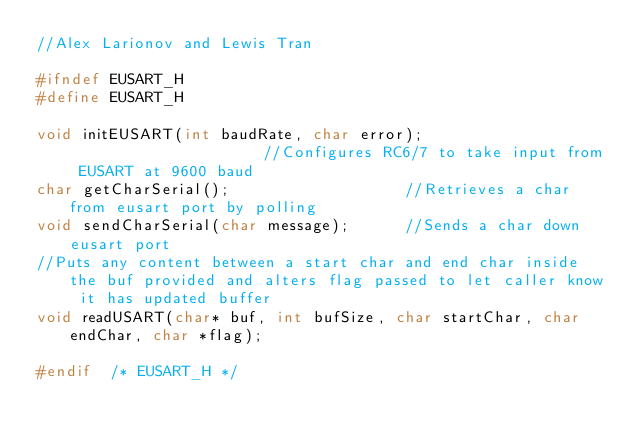<code> <loc_0><loc_0><loc_500><loc_500><_C_>//Alex Larionov and Lewis Tran

#ifndef EUSART_H
#define	EUSART_H

void initEUSART(int baudRate, char error);                      //Configures RC6/7 to take input from EUSART at 9600 baud
char getCharSerial();                   //Retrieves a char from eusart port by polling
void sendCharSerial(char message);      //Sends a char down eusart port 
//Puts any content between a start char and end char inside the buf provided and alters flag passed to let caller know it has updated buffer
void readUSART(char* buf, int bufSize, char startChar, char endChar, char *flag);   

#endif	/* EUSART_H */

</code> 